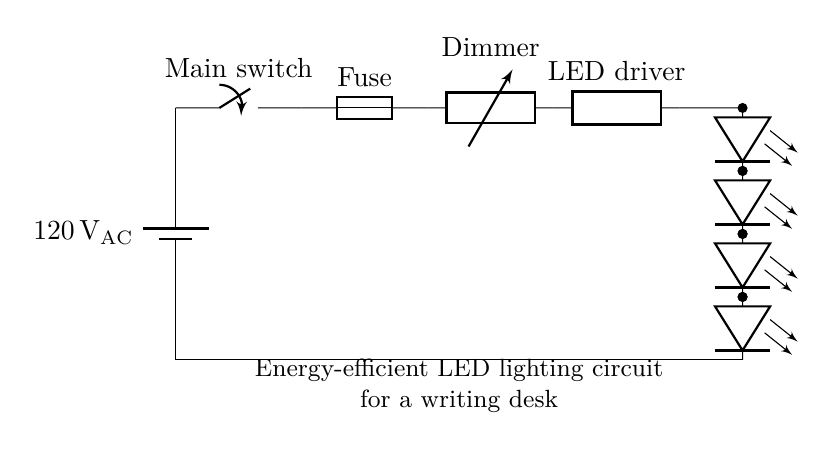What is the main voltage rating of this circuit? The voltage rating is shown on the battery symbol in the circuit diagram. It specifies that the circuit operates at 120 volts alternating current.
Answer: 120 volts What component is used to control the brightness in the circuit? The component responsible for brightness control is the dimmer switch, indicated as 'Dimmer' in the circuit diagram.
Answer: Dimmer switch How many LEDs are connected in this circuit? The circuit diagram shows a vertical arrangement of LEDs, specifically five individual LEDs stacked one above the other.
Answer: Five LEDs What is placed between the power supply and the dimmer? The fuse is located between the power source and the dimmer switch, which serves as a safety device to prevent overcurrent.
Answer: Fuse Which component converts the mains voltage for the LED array? The LED driver is the component that converts the alternating mains voltage into a suitable form for operating the LED array, facilitating the connection between the dimmer and LEDs.
Answer: LED driver What is the purpose of the main switch in this circuit? The main switch allows for the control of the entire circuit, enabling the user to turn the lighting on or off as desired.
Answer: Control circuit What is the purpose of the ground connection in this circuit? The ground connection provides a reference point for the voltage levels in the circuit and enhances safety by reducing the risk of electrical shock.
Answer: Safety reference 